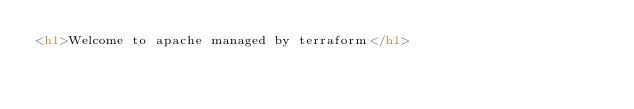<code> <loc_0><loc_0><loc_500><loc_500><_HTML_><h1>Welcome to apache managed by terraform</h1></code> 